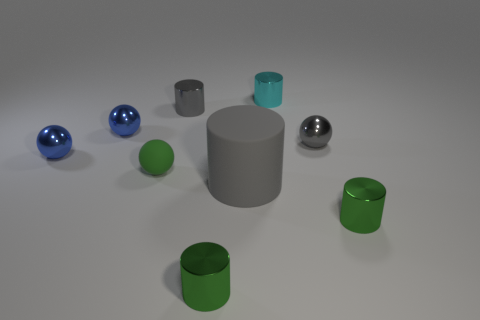Subtract all gray spheres. How many spheres are left? 3 Subtract all cyan cylinders. How many cylinders are left? 4 Subtract all spheres. How many objects are left? 5 Add 5 tiny cyan shiny blocks. How many tiny cyan shiny blocks exist? 5 Add 1 big gray things. How many objects exist? 10 Subtract 0 red spheres. How many objects are left? 9 Subtract 4 spheres. How many spheres are left? 0 Subtract all yellow balls. Subtract all red cubes. How many balls are left? 4 Subtract all gray cubes. How many yellow balls are left? 0 Subtract all green things. Subtract all gray rubber cylinders. How many objects are left? 5 